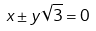Convert formula to latex. <formula><loc_0><loc_0><loc_500><loc_500>x \pm y \sqrt { 3 } = 0</formula> 